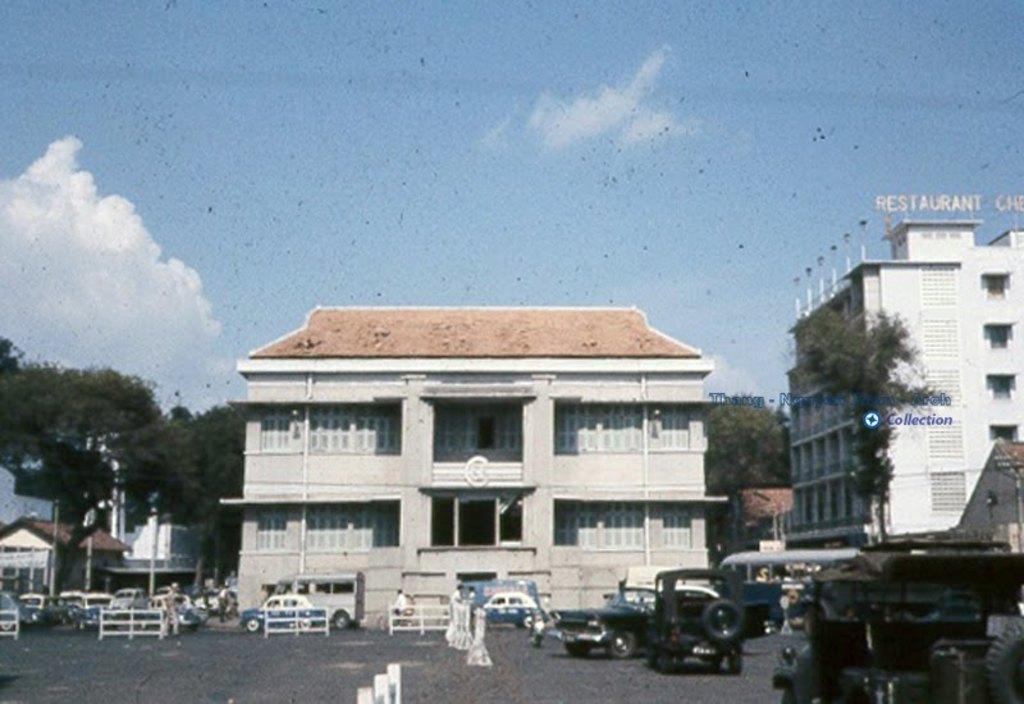What can be seen on the road in the image? There are vehicles on the road in the image. Who or what else is present in the image? There is a group of people in the image. What structures are visible in the image? There are buildings in the image. What type of natural elements can be seen in the image? There are trees in the image. What is visible in the background of the image? The sky is visible in the background of the image. What type of destruction can be seen in the image? There is no destruction present in the image; it features vehicles, people, buildings, trees, and the sky. How many parts of the bushes can be counted in the image? There are no bushes present in the image; it features vehicles, people, buildings, trees, and the sky. 